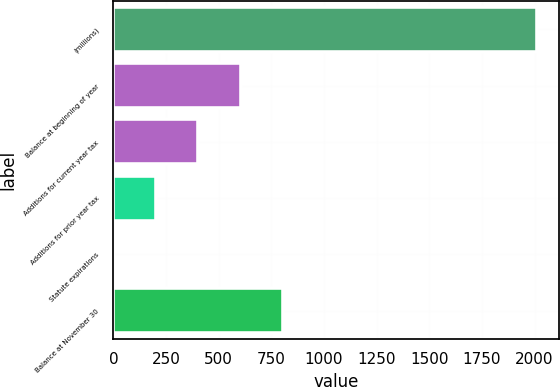<chart> <loc_0><loc_0><loc_500><loc_500><bar_chart><fcel>(millions)<fcel>Balance at beginning of year<fcel>Additions for current year tax<fcel>Additions for prior year tax<fcel>Statute expirations<fcel>Balance at November 30<nl><fcel>2013<fcel>603.97<fcel>402.68<fcel>201.39<fcel>0.1<fcel>805.26<nl></chart> 